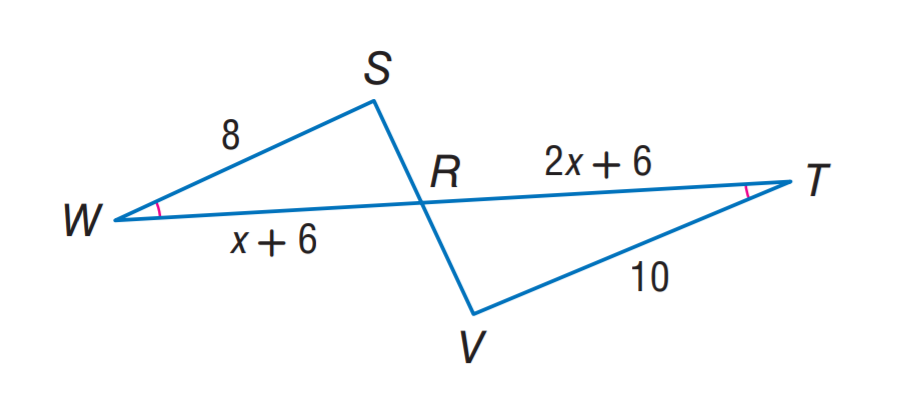Question: Find R T.
Choices:
A. 6
B. 8
C. 10
D. 12
Answer with the letter. Answer: C 